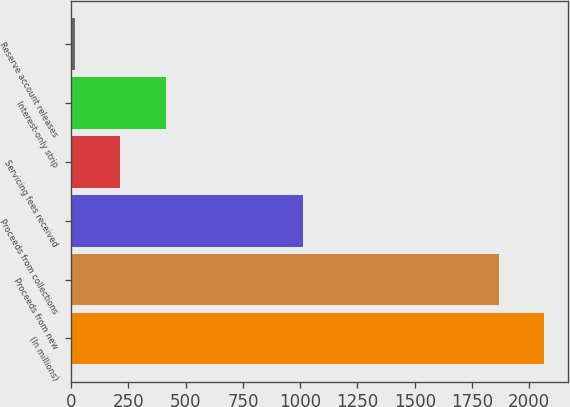Convert chart to OTSL. <chart><loc_0><loc_0><loc_500><loc_500><bar_chart><fcel>(In millions)<fcel>Proceeds from new<fcel>Proceeds from collections<fcel>Servicing fees received<fcel>Interest-only strip<fcel>Reserve account releases<nl><fcel>2066.68<fcel>1867.5<fcel>1011.8<fcel>214.38<fcel>413.56<fcel>15.2<nl></chart> 